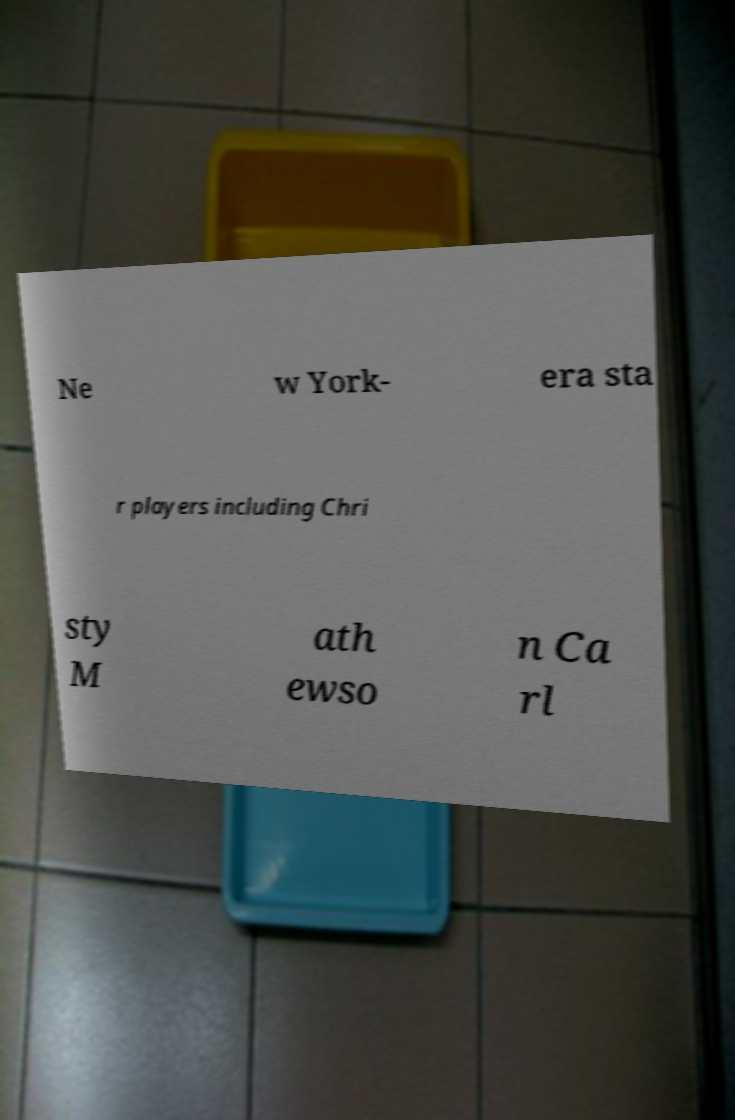I need the written content from this picture converted into text. Can you do that? Ne w York- era sta r players including Chri sty M ath ewso n Ca rl 